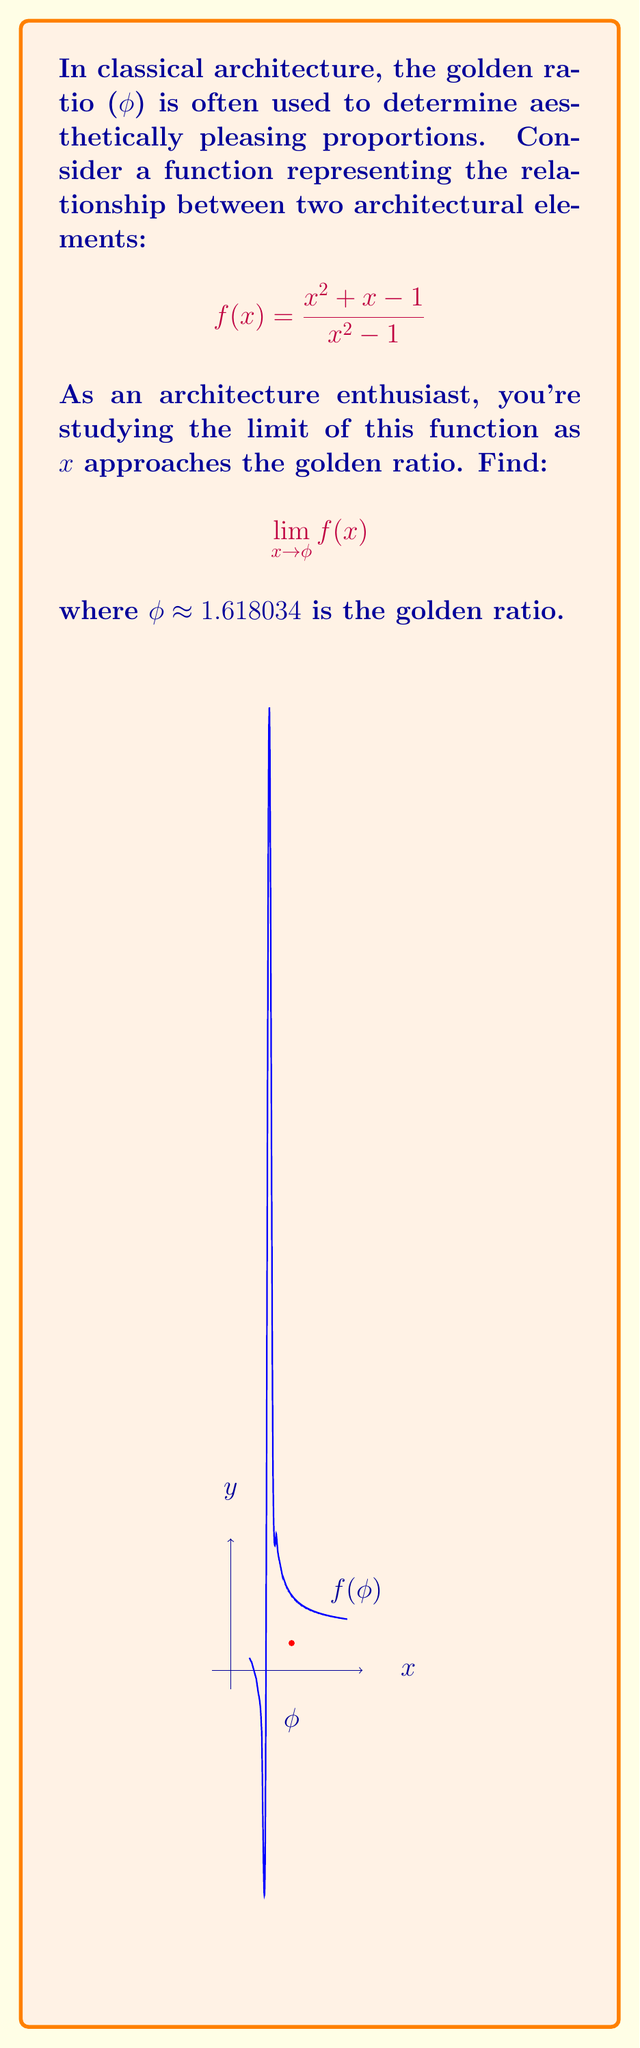Could you help me with this problem? Let's approach this step-by-step:

1) First, recall that the golden ratio φ is the positive solution to the equation x^2 = x + 1. This means:

   $$\phi^2 = \phi + 1$$

2) Now, let's consider our limit:

   $$\lim_{x \to \phi} \frac{x^2 + x - 1}{x^2 - 1}$$

3) If we directly substitute x = φ, we get:

   $$\frac{\phi^2 + \phi - 1}{\phi^2 - 1}$$

4) Using the property of φ from step 1, we can replace φ^2 with φ + 1 in both numerator and denominator:

   $$\frac{(\phi + 1) + \phi - 1}{(\phi + 1) - 1} = \frac{2\phi}{φ} = 2$$

5) This direct substitution works because the function is defined at x = φ. The denominator is not zero because φ^2 - 1 = (φ + 1) - 1 = φ ≠ 0.

6) To verify, we can also use the actual value of φ:

   $$\phi = \frac{1 + \sqrt{5}}{2} \approx 1.618034$$

   Plugging this into f(x) would give us a result very close to 2.
Answer: $$2$$ 